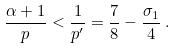<formula> <loc_0><loc_0><loc_500><loc_500>\frac { \alpha + 1 } { p } < \frac { 1 } { p ^ { \prime } } = \frac { 7 } { 8 } - \frac { \sigma _ { 1 } } { 4 } \, .</formula> 